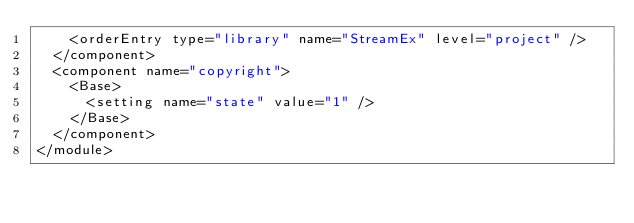Convert code to text. <code><loc_0><loc_0><loc_500><loc_500><_XML_>    <orderEntry type="library" name="StreamEx" level="project" />
  </component>
  <component name="copyright">
    <Base>
      <setting name="state" value="1" />
    </Base>
  </component>
</module></code> 